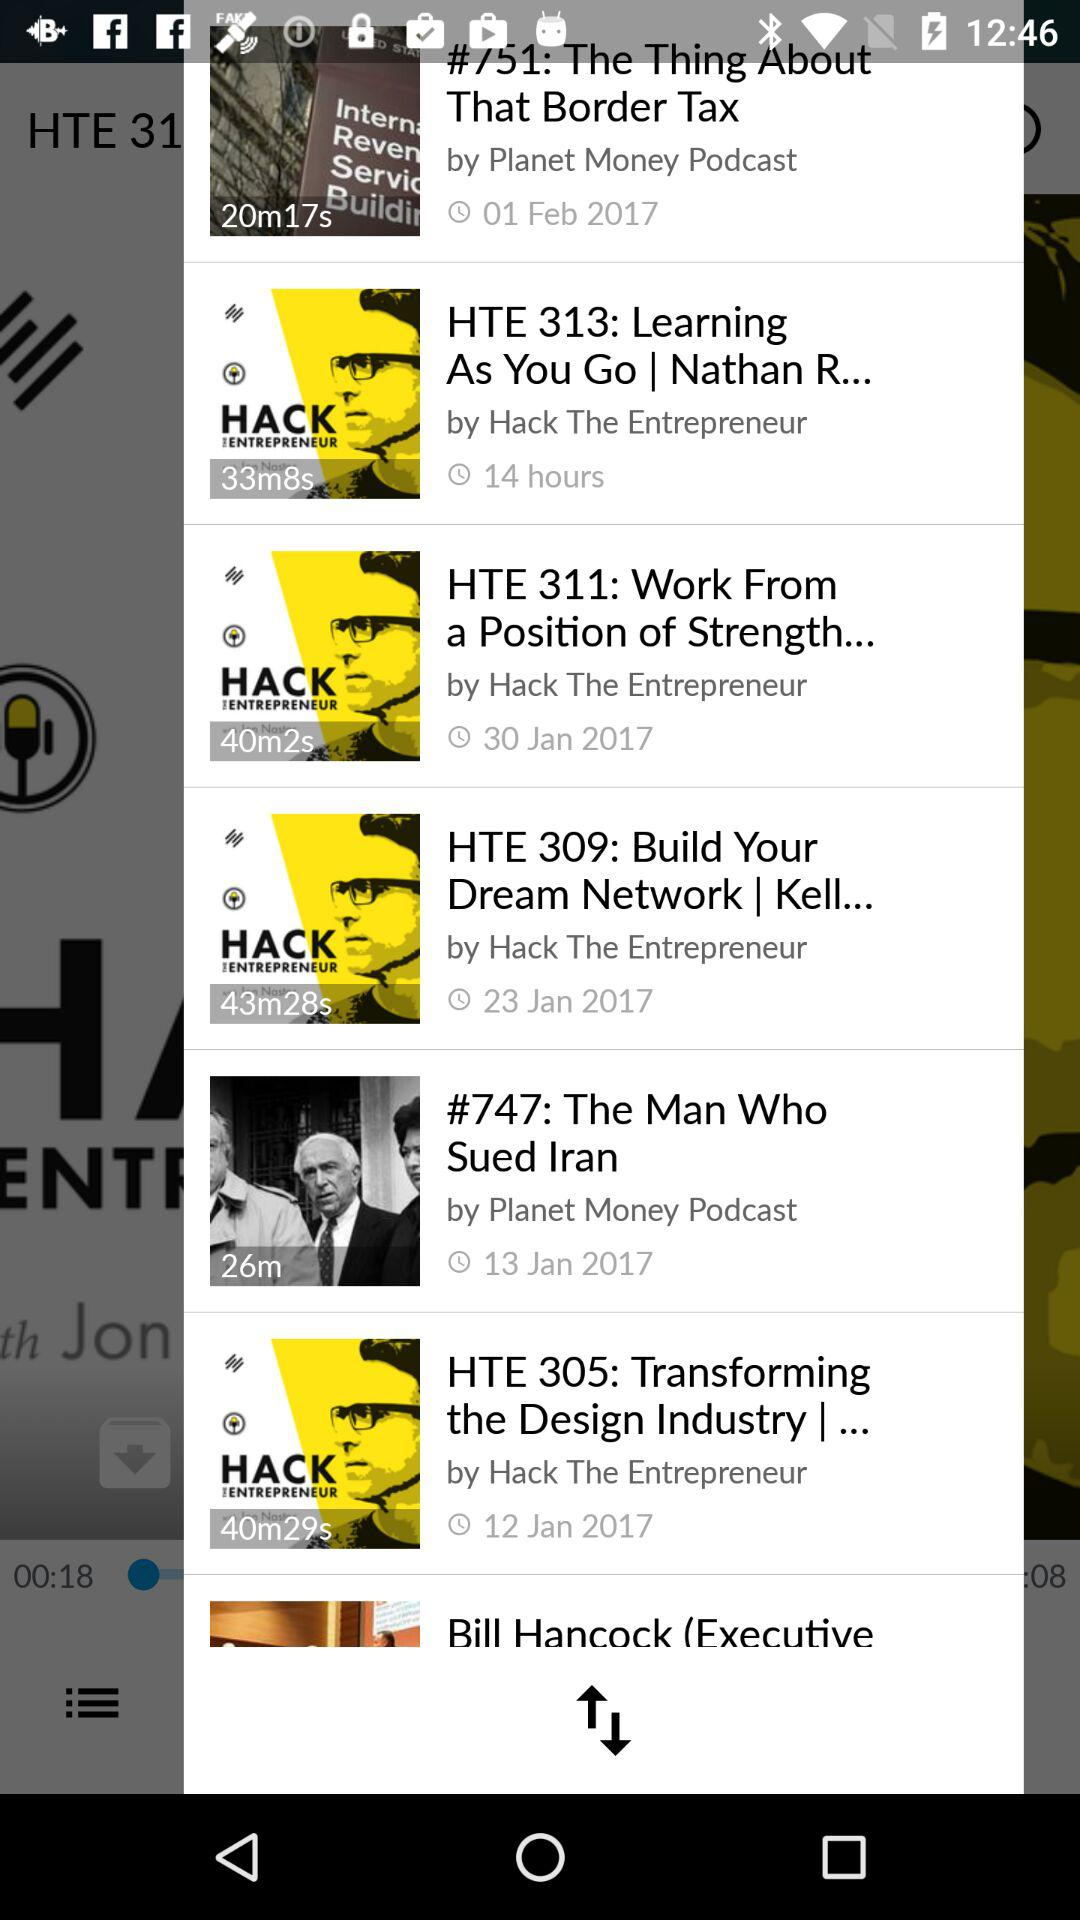What is the duration of "HTE 311: Work From a Position of Strength..."? The duration is 40 minutes and 2 seconds. 